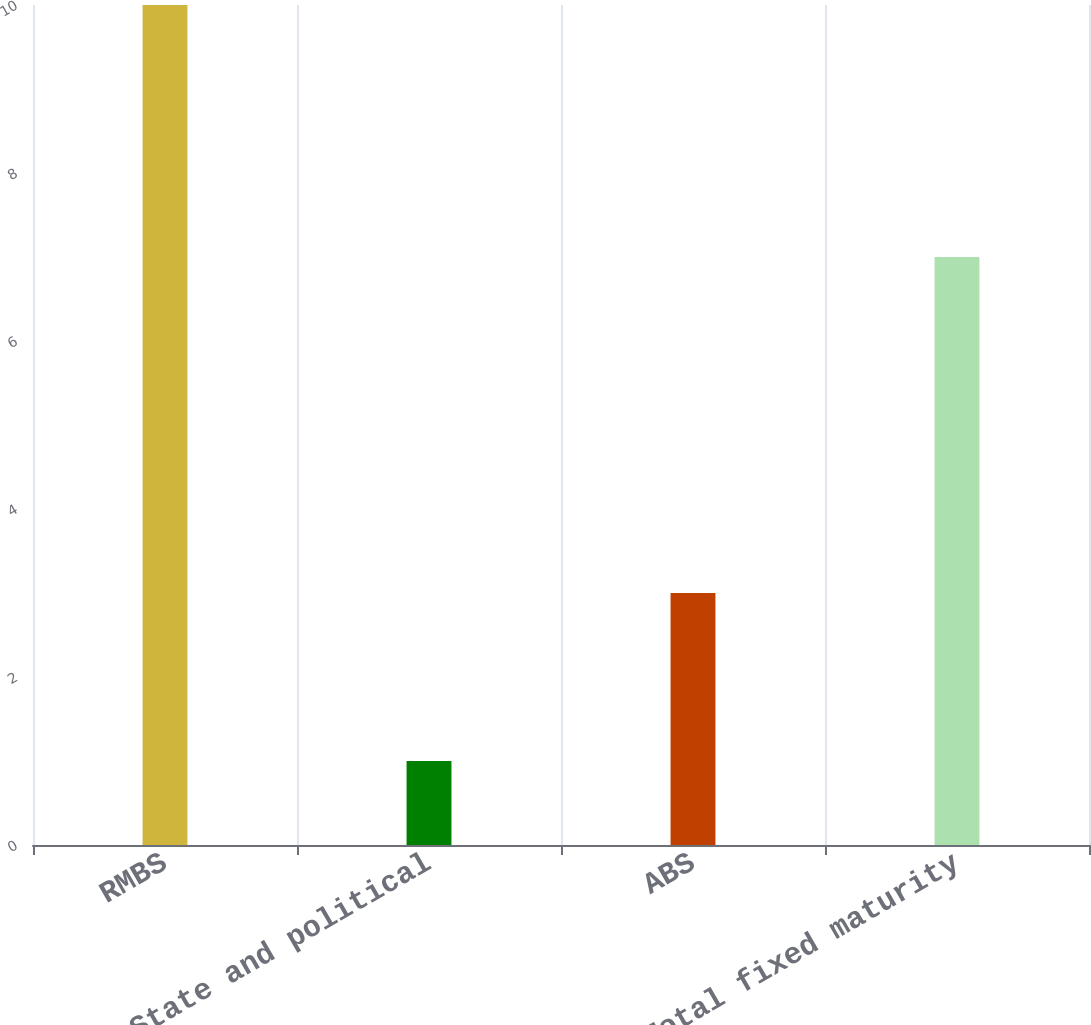Convert chart. <chart><loc_0><loc_0><loc_500><loc_500><bar_chart><fcel>RMBS<fcel>State and political<fcel>ABS<fcel>Total fixed maturity<nl><fcel>10<fcel>1<fcel>3<fcel>7<nl></chart> 